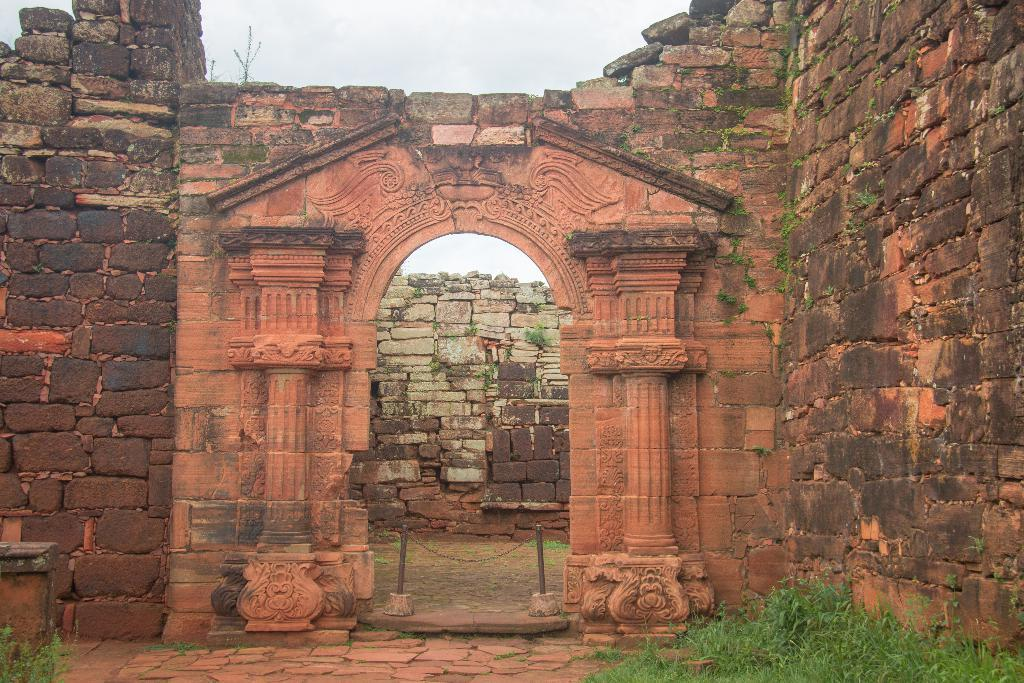What type of structure is visible in the image? There is a building in the image. What type of vegetation can be seen in the image? There is green grass in the image. What are the poles used for in the image? The purpose of the poles is not specified, but they are visible in the image. What is the color of the sky in the image? The sky is blue in color. Is there any chain visible in the image? Yes, there is a chain in the image. What is the name of the daughter of the person who owns the building in the image? There is no information about the owner of the building or their daughter in the image. 